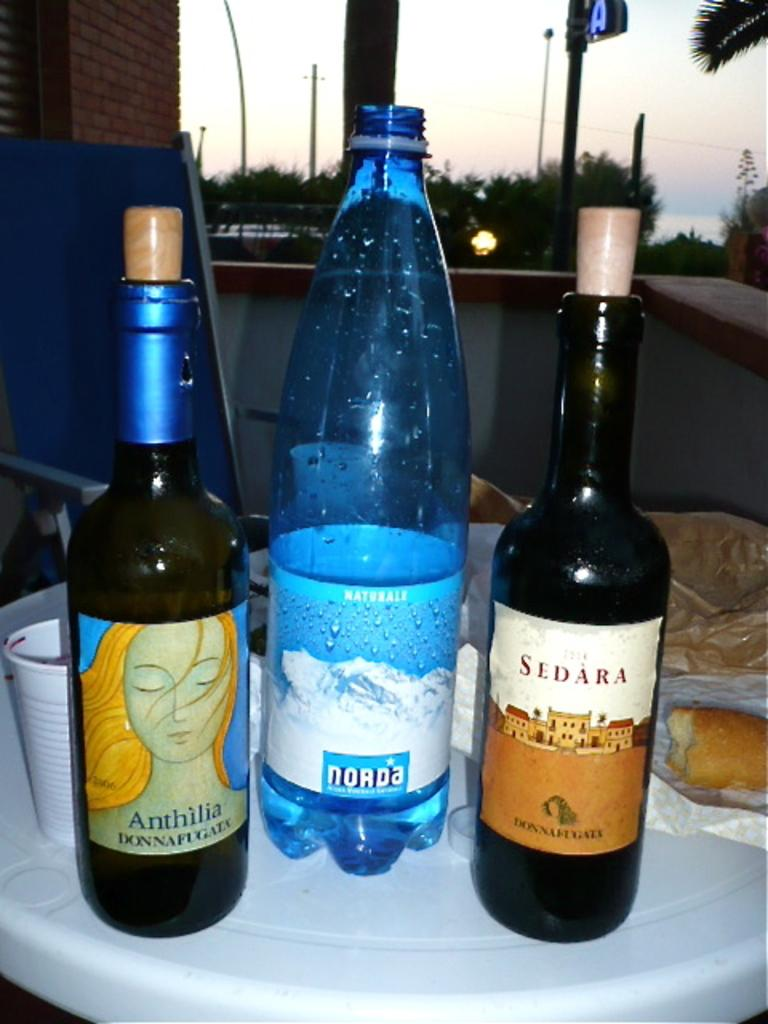<image>
Give a short and clear explanation of the subsequent image. Three bottles on a table, the one on the left bearing the word Sedara. 